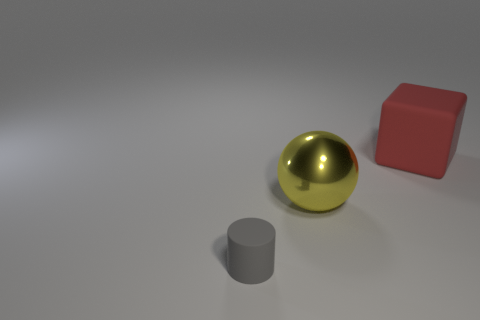Add 3 rubber cylinders. How many objects exist? 6 Subtract all cubes. How many objects are left? 2 Subtract 1 yellow balls. How many objects are left? 2 Subtract all large green rubber cubes. Subtract all gray rubber things. How many objects are left? 2 Add 2 small objects. How many small objects are left? 3 Add 3 large red matte cubes. How many large red matte cubes exist? 4 